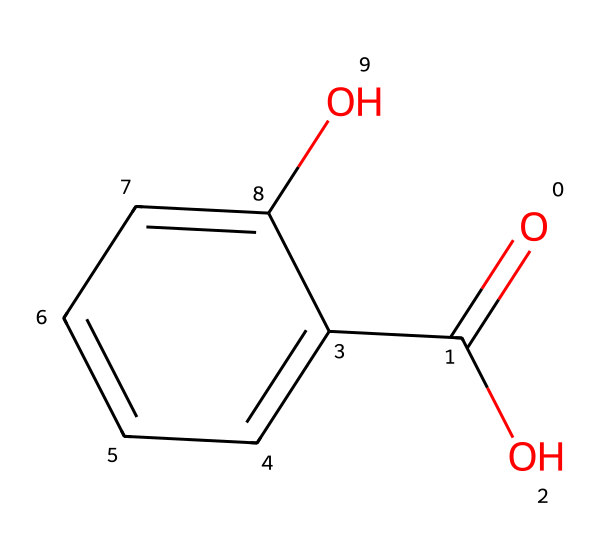What is the name of this chemical? The chemical structure represents salicylic acid, which is an aromatic compound with a carboxylic acid functional group.
Answer: salicylic acid How many carbon atoms are in salicylic acid? The SMILES notation indicates a total of seven carbon atoms (C) in the structure, including those in the benzene ring and the carboxylic acid group.
Answer: seven How many hydroxyl groups are present in the structure? There is one hydroxyl (OH) group attached to the benzene ring, indicating the presence of one hydroxyl group in salicylic acid.
Answer: one What type of acid is salicylic acid? Salicylic acid is classified as a weak organic acid due to its ability to partially dissociate in solution and the presence of the carboxylic acid functional group (-COOH).
Answer: weak organic acid What functional groups are present in salicylic acid? The chemical structure shows two functional groups: a carboxylic acid group (-COOH) and a hydroxyl group (-OH), characteristic of salicylic acid.
Answer: carboxylic acid and hydroxyl How does the carboxylic acid group affect its acidic properties? The carboxylic acid group can donate a hydrogen ion (H+) to a solution, which increases the acidity of salicylic acid compared to compounds without this group.
Answer: increases acidity Why is salicylic acid considered effective for pain relief? Salicylic acid functions as a cyclooxygenase inhibitor, reducing the synthesis of prostaglandins that trigger pain and inflammation, thus providing analgesic effects.
Answer: analgesic effects 